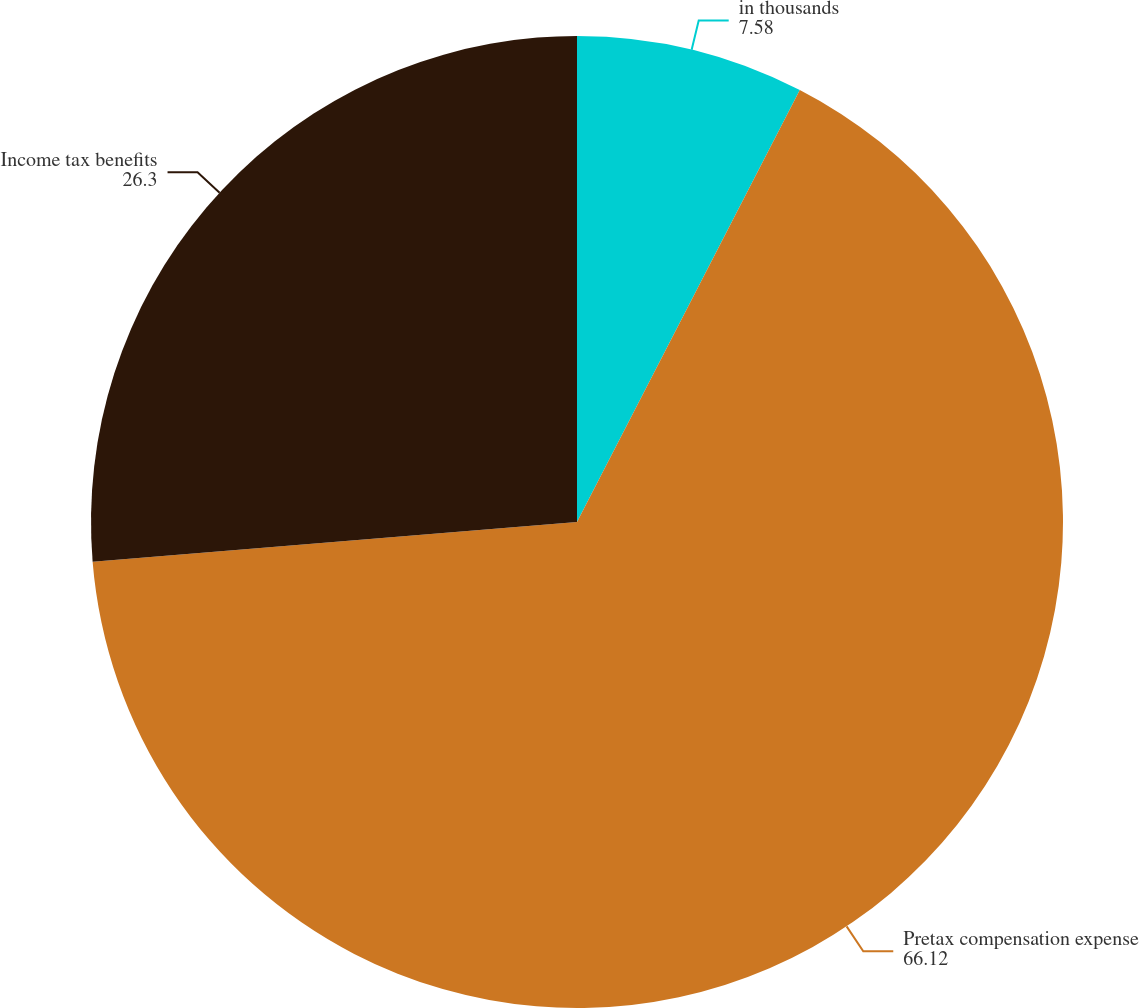Convert chart. <chart><loc_0><loc_0><loc_500><loc_500><pie_chart><fcel>in thousands<fcel>Pretax compensation expense<fcel>Income tax benefits<nl><fcel>7.58%<fcel>66.12%<fcel>26.3%<nl></chart> 